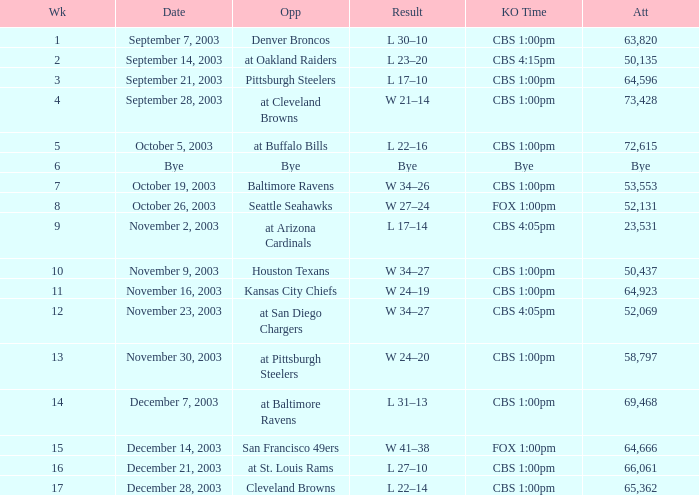What is the average number of weeks that the opponent was the Denver Broncos? 1.0. 